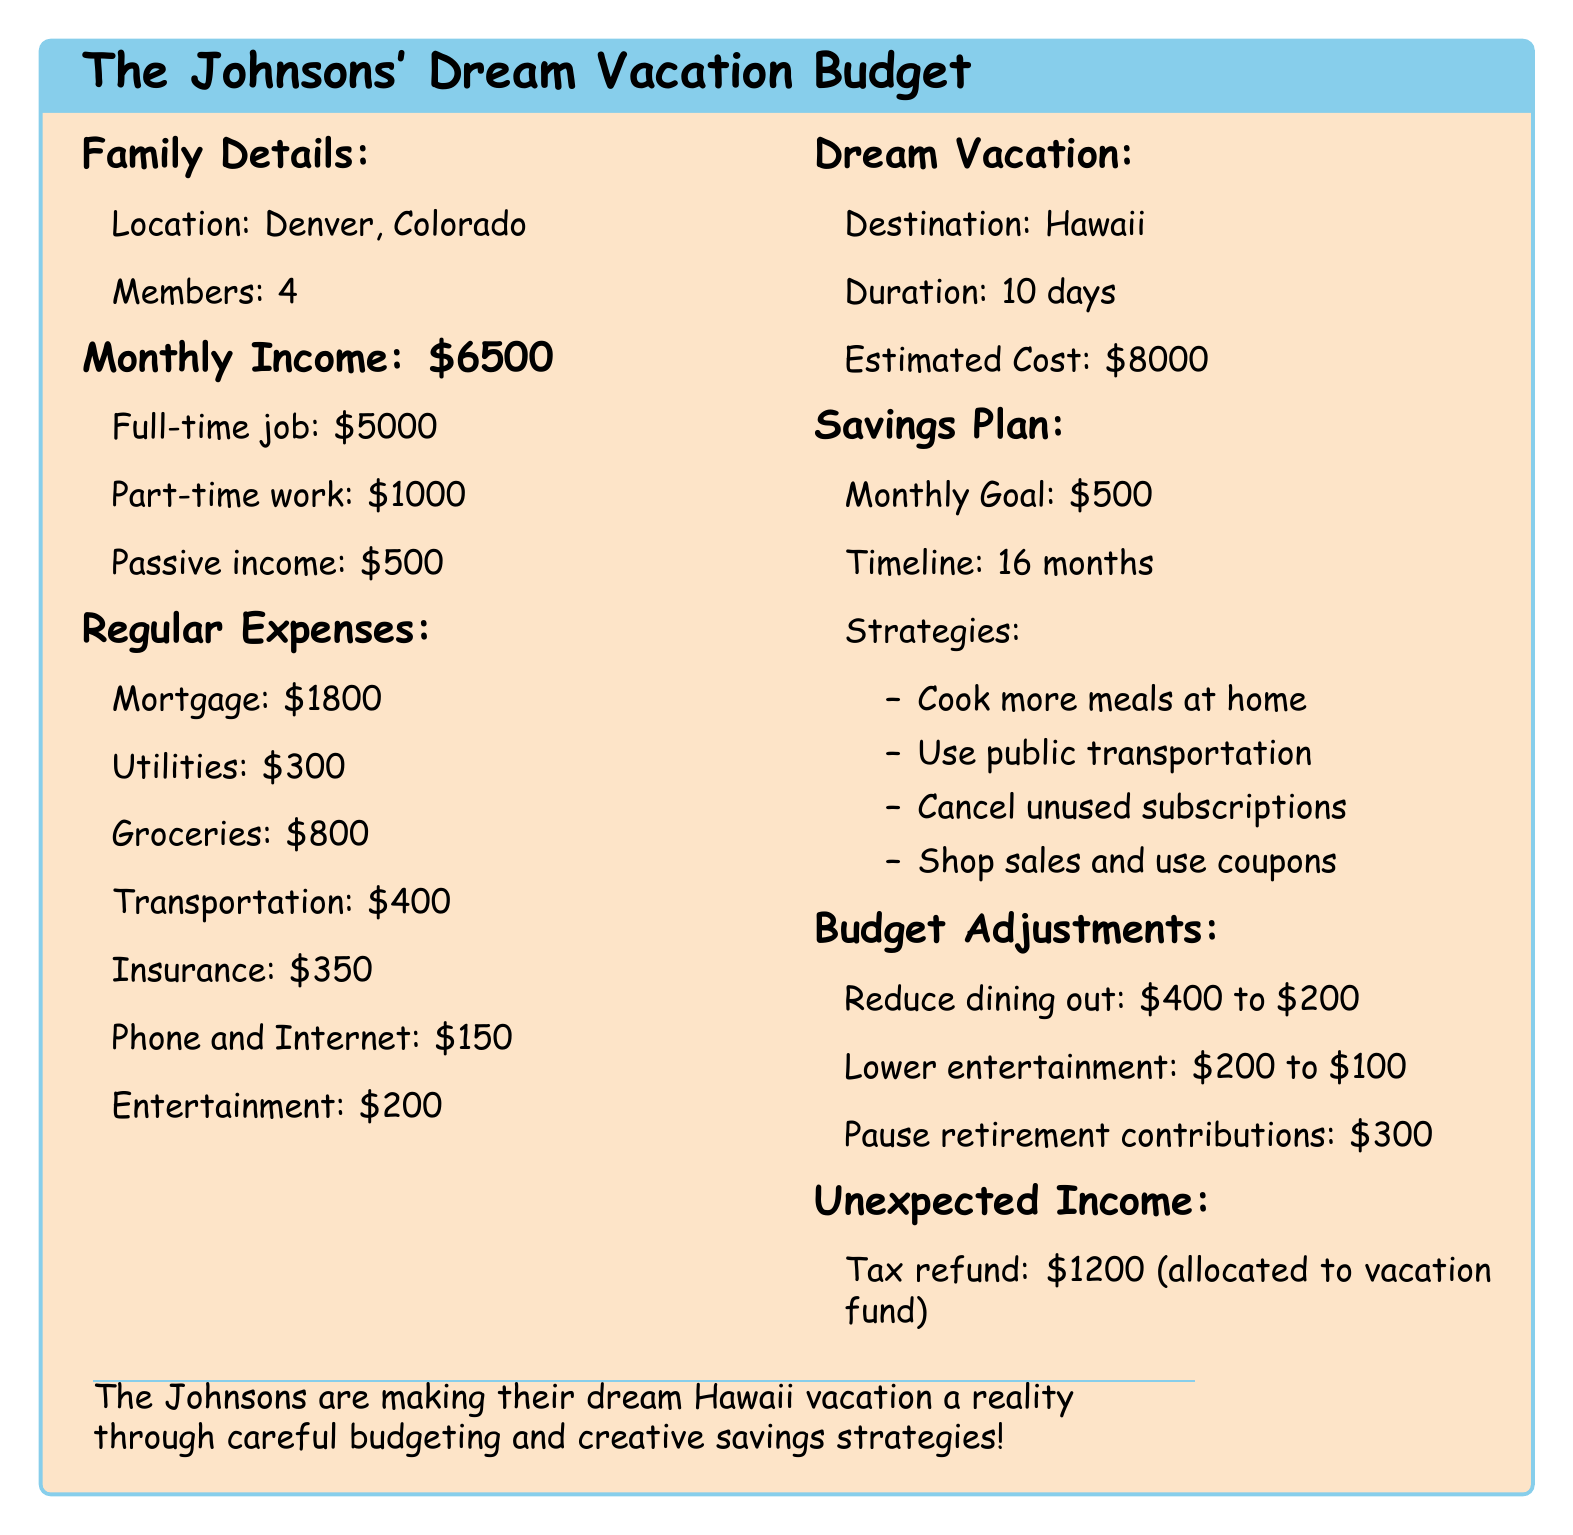What is the family's total monthly income? The family's total monthly income is listed as \$6500.
Answer: \$6500 What is the estimated cost of the dream vacation? The estimated cost of the dream vacation to Hawaii is clearly stated as \$8000.
Answer: \$8000 How many months will it take to save for the vacation? The timeline for saving for the vacation is mentioned as 16 months.
Answer: 16 months What amount do the Johnsons plan to save each month? The monthly savings goal is specified as \$500.
Answer: \$500 Which strategies are included in the savings plan? Strategies in the savings plan include cooking at home, using public transport, and canceling subscriptions.
Answer: Cooking more meals at home, using public transportation, cancel unused subscriptions, shop sales and use coupons What is one major budget adjustment the Johnsons are planning? One major budget adjustment stated is reducing dining out expenses from \$400 to \$200.
Answer: Reduce dining out: \$400 to \$200 How much did the Johnsons allocate from their tax refund? The document specifies that they allocated \$1200 from their tax refund to the vacation fund.
Answer: \$1200 What is the duration of the planned vacation? The duration of the planned vacation is stated as 10 days.
Answer: 10 days 